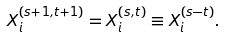<formula> <loc_0><loc_0><loc_500><loc_500>X _ { i } ^ { ( s + 1 , t + 1 ) } = X _ { i } ^ { ( s , t ) } \equiv X _ { i } ^ { ( s - t ) } .</formula> 